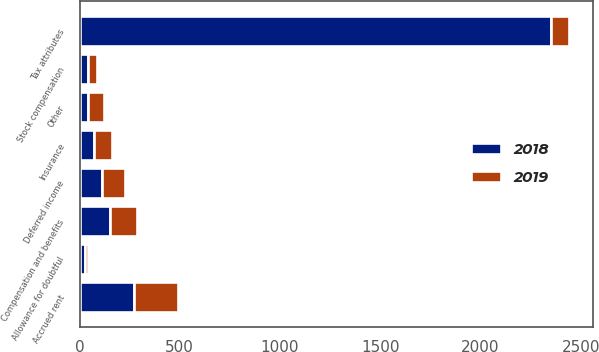Convert chart to OTSL. <chart><loc_0><loc_0><loc_500><loc_500><stacked_bar_chart><ecel><fcel>Compensation and benefits<fcel>Insurance<fcel>Accrued rent<fcel>Allowance for doubtful<fcel>Tax attributes<fcel>Stock compensation<fcel>Deferred income<fcel>Other<nl><fcel>2019<fcel>133<fcel>90<fcel>219<fcel>13<fcel>90<fcel>45<fcel>115<fcel>78<nl><fcel>2018<fcel>152<fcel>74<fcel>271<fcel>27<fcel>2351<fcel>44<fcel>110<fcel>44<nl></chart> 